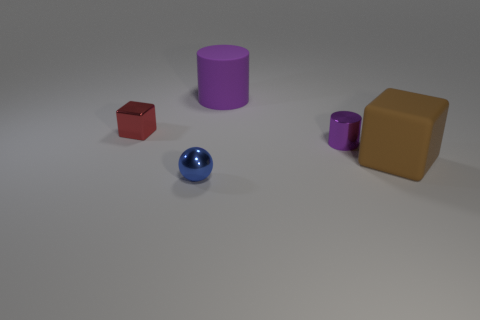There is a shiny object to the right of the big purple rubber thing; does it have the same shape as the big object in front of the tiny cylinder? no 